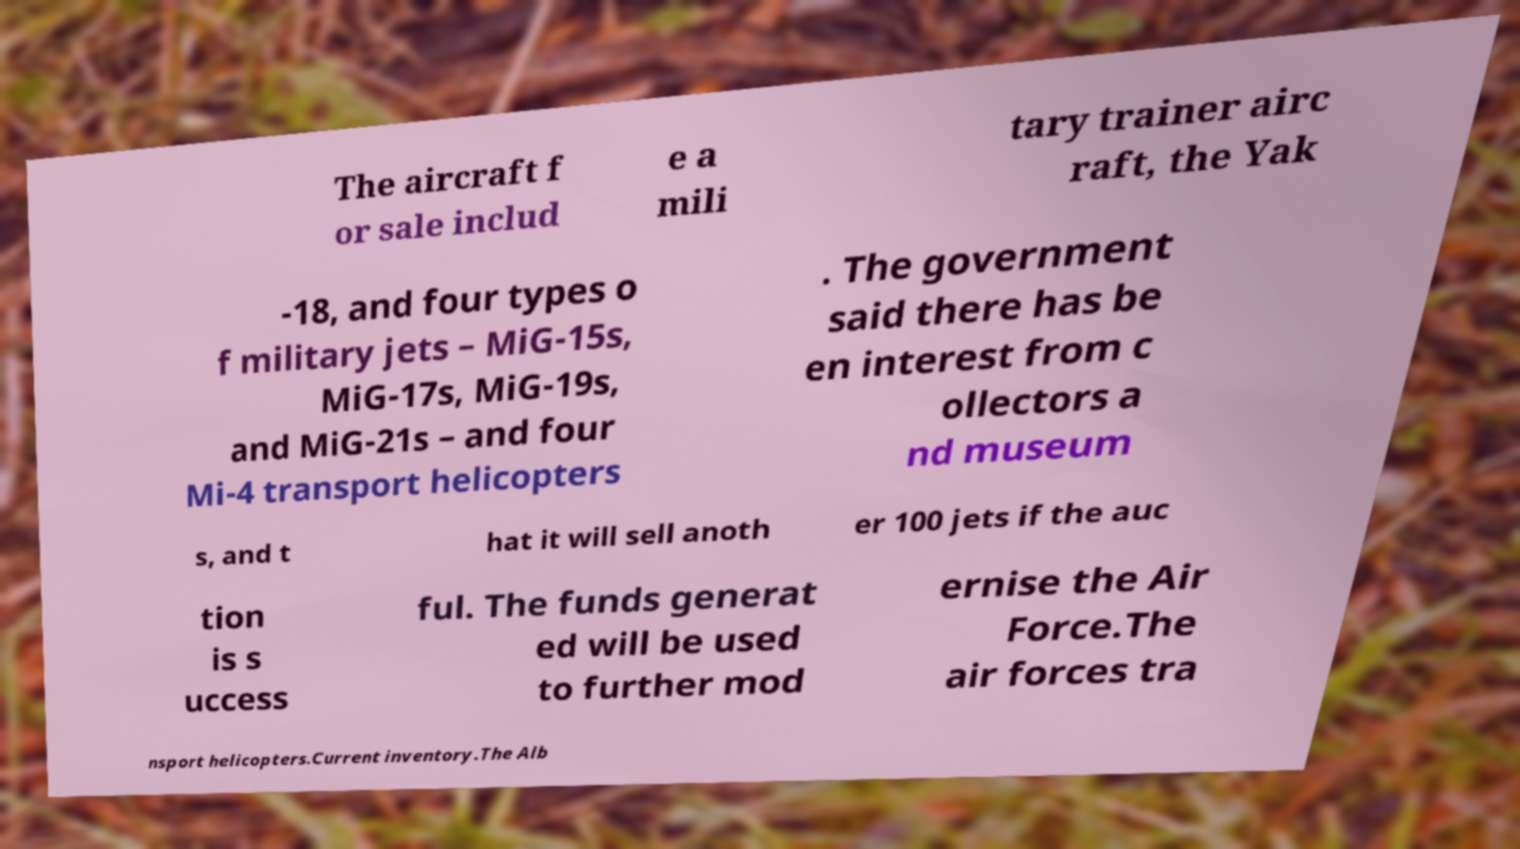There's text embedded in this image that I need extracted. Can you transcribe it verbatim? The aircraft f or sale includ e a mili tary trainer airc raft, the Yak -18, and four types o f military jets – MiG-15s, MiG-17s, MiG-19s, and MiG-21s – and four Mi-4 transport helicopters . The government said there has be en interest from c ollectors a nd museum s, and t hat it will sell anoth er 100 jets if the auc tion is s uccess ful. The funds generat ed will be used to further mod ernise the Air Force.The air forces tra nsport helicopters.Current inventory.The Alb 